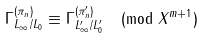Convert formula to latex. <formula><loc_0><loc_0><loc_500><loc_500>\Gamma _ { L _ { \infty } / L _ { 0 } } ^ { ( \pi _ { n } ) } \equiv \Gamma _ { L _ { \infty } ^ { \prime } / L _ { 0 } ^ { \prime } } ^ { ( \pi _ { n } ^ { \prime } ) } \pmod { X ^ { m + 1 } }</formula> 